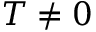Convert formula to latex. <formula><loc_0><loc_0><loc_500><loc_500>T \neq 0</formula> 